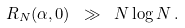Convert formula to latex. <formula><loc_0><loc_0><loc_500><loc_500>R _ { N } ( \alpha , 0 ) \ \gg \ N \log N \, .</formula> 